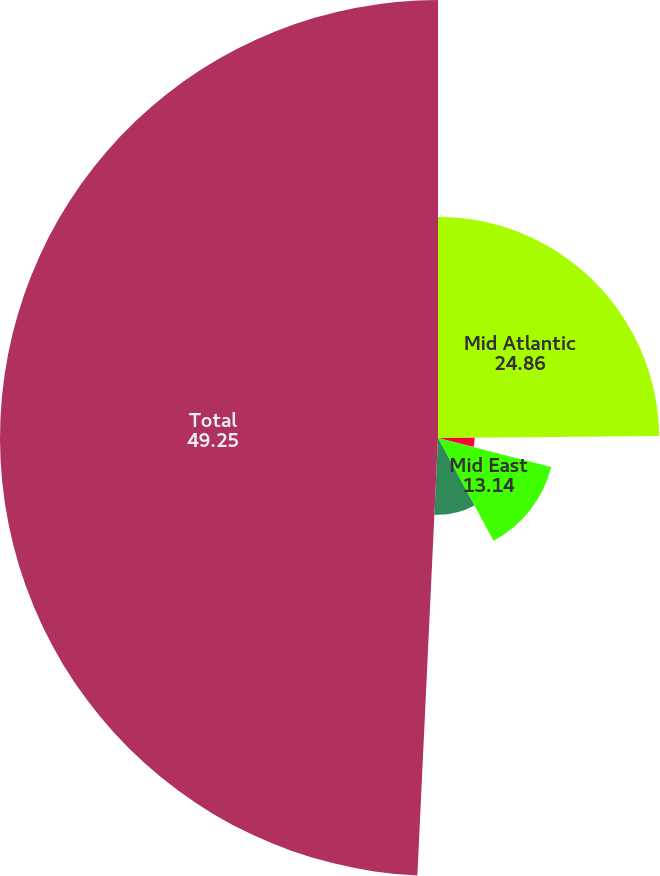<chart> <loc_0><loc_0><loc_500><loc_500><pie_chart><fcel>Mid Atlantic<fcel>North East<fcel>Mid East<fcel>South East<fcel>Total<nl><fcel>24.86%<fcel>4.12%<fcel>13.14%<fcel>8.63%<fcel>49.25%<nl></chart> 